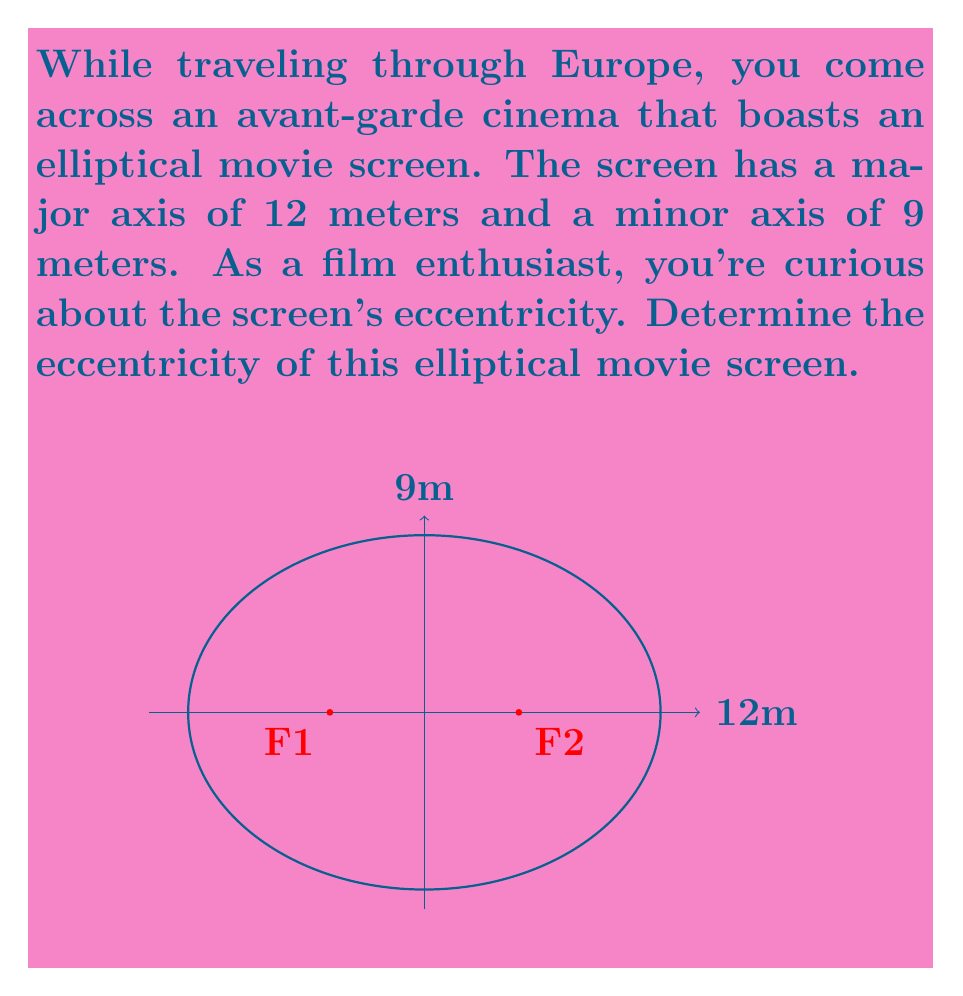Solve this math problem. Let's approach this step-by-step:

1) The eccentricity (e) of an ellipse is given by the formula:

   $$e = \sqrt{1 - \frac{b^2}{a^2}}$$

   where $a$ is the semi-major axis and $b$ is the semi-minor axis.

2) We're given the full lengths of the axes, so we need to halve them:
   - Semi-major axis $a = 12/2 = 6$ meters
   - Semi-minor axis $b = 9/2 = 4.5$ meters

3) Now, let's substitute these values into our formula:

   $$e = \sqrt{1 - \frac{(4.5)^2}{6^2}}$$

4) Simplify inside the parentheses:
   
   $$e = \sqrt{1 - \frac{20.25}{36}}$$

5) Divide:

   $$e = \sqrt{1 - 0.5625}$$

6) Subtract:

   $$e = \sqrt{0.4375}$$

7) Take the square root:

   $$e \approx 0.6614$$

Thus, the eccentricity of the elliptical movie screen is approximately 0.6614.
Answer: $e \approx 0.6614$ 